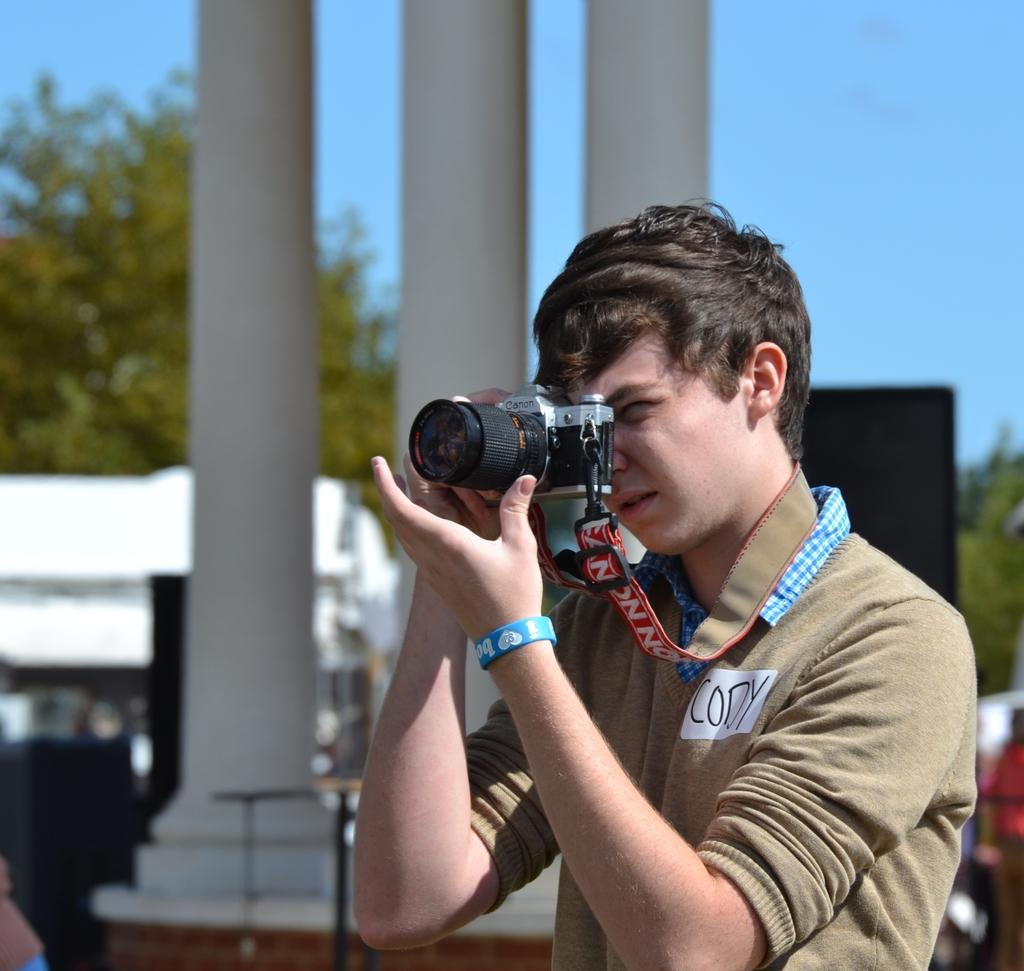Who is in the image? There is a person in the image. What is the person holding? The person is holding a camera. What can be seen in the background of the image? Pillars and trees are visible in the background of the image. How many sheep are visible in the image? There are no sheep present in the image. What type of hospital can be seen in the background of the image? There is no hospital visible in the image; only pillars and trees are present in the background. 